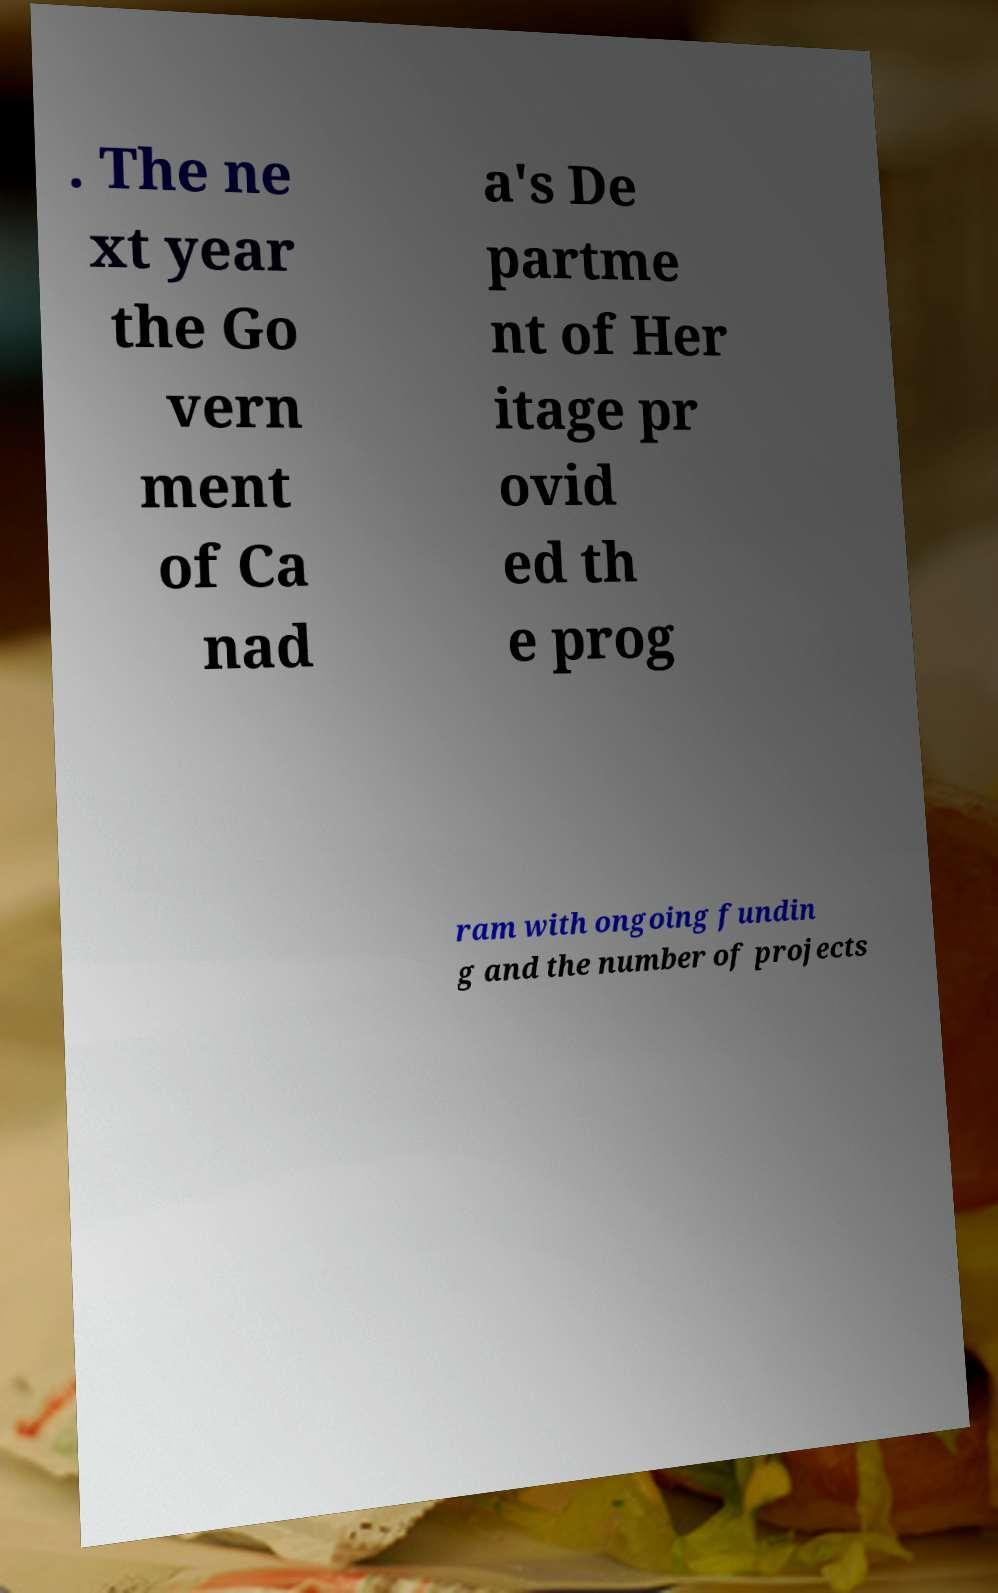For documentation purposes, I need the text within this image transcribed. Could you provide that? . The ne xt year the Go vern ment of Ca nad a's De partme nt of Her itage pr ovid ed th e prog ram with ongoing fundin g and the number of projects 